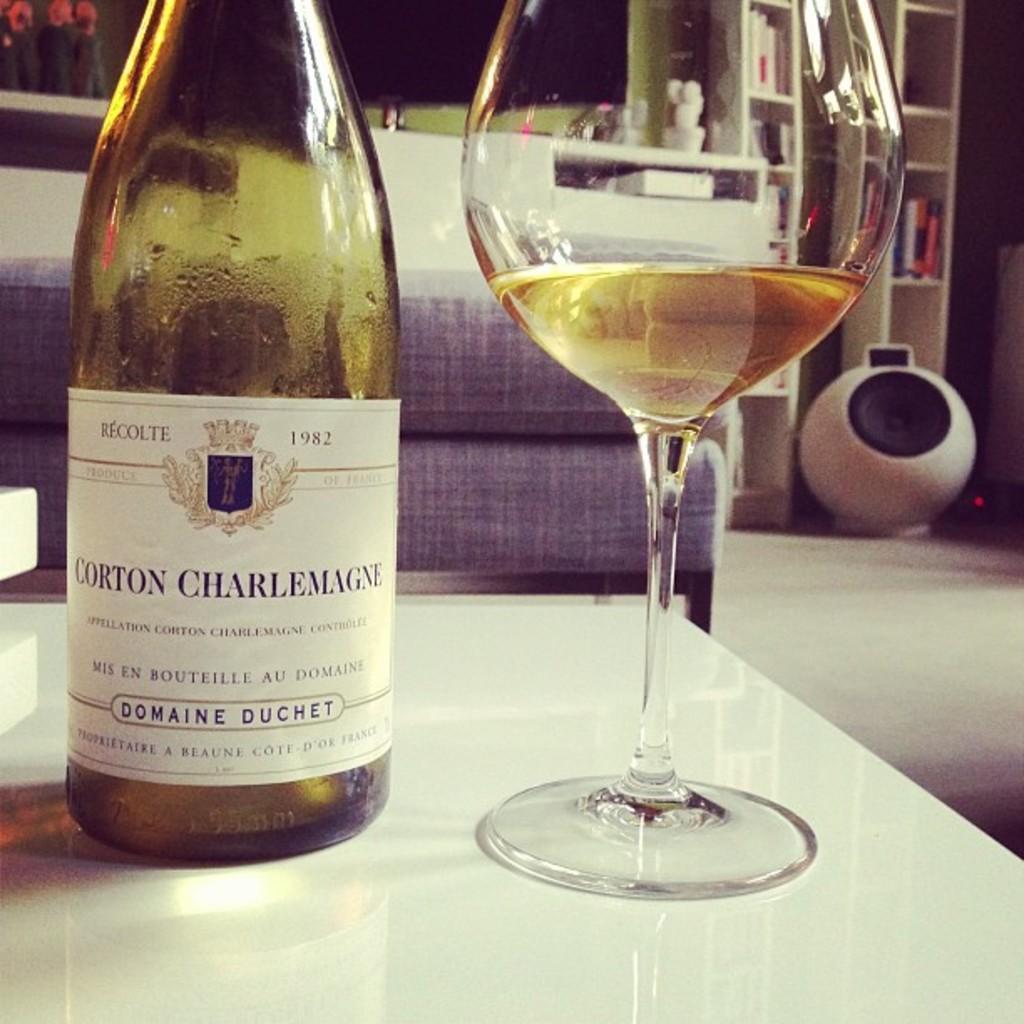How would you summarize this image in a sentence or two? This is a wine bottle which is green in color. This is a wine glass with wine placed on the table which is white in color. This looks like a couch. At background I can see books placed at the bookshelf. I can see another object here,I think this is speaker. 